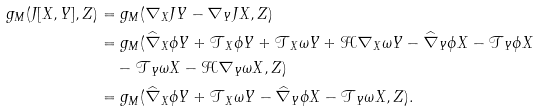Convert formula to latex. <formula><loc_0><loc_0><loc_500><loc_500>g _ { M } ( J [ X , Y ] , Z ) & = g _ { M } ( \nabla _ { X } J Y - \nabla _ { Y } J X , Z ) \\ & = g _ { M } ( \widehat { \nabla } _ { X } \phi Y + \mathcal { T } _ { X } \phi Y + \mathcal { T } _ { X } \omega Y + \mathcal { H } \nabla _ { X } \omega Y - \widehat { \nabla } _ { Y } \phi X - \mathcal { T } _ { Y } \phi X \\ & \quad - \mathcal { T } _ { Y } \omega X - \mathcal { H } \nabla _ { Y } \omega X , Z ) \\ & = g _ { M } ( \widehat { \nabla } _ { X } \phi Y + \mathcal { T } _ { X } \omega Y - \widehat { \nabla } _ { Y } \phi X - \mathcal { T } _ { Y } \omega X , Z ) .</formula> 